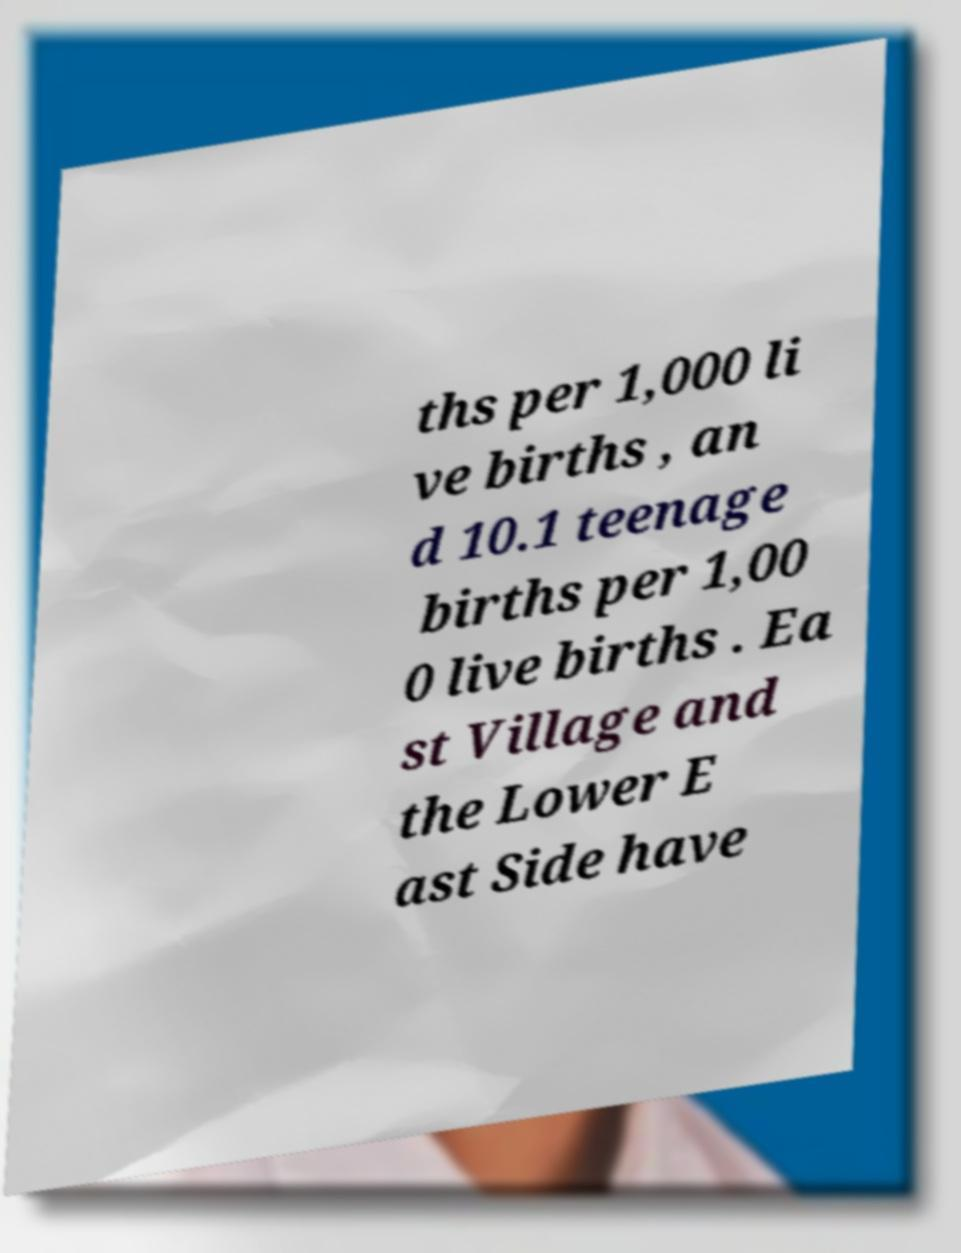Please identify and transcribe the text found in this image. ths per 1,000 li ve births , an d 10.1 teenage births per 1,00 0 live births . Ea st Village and the Lower E ast Side have 